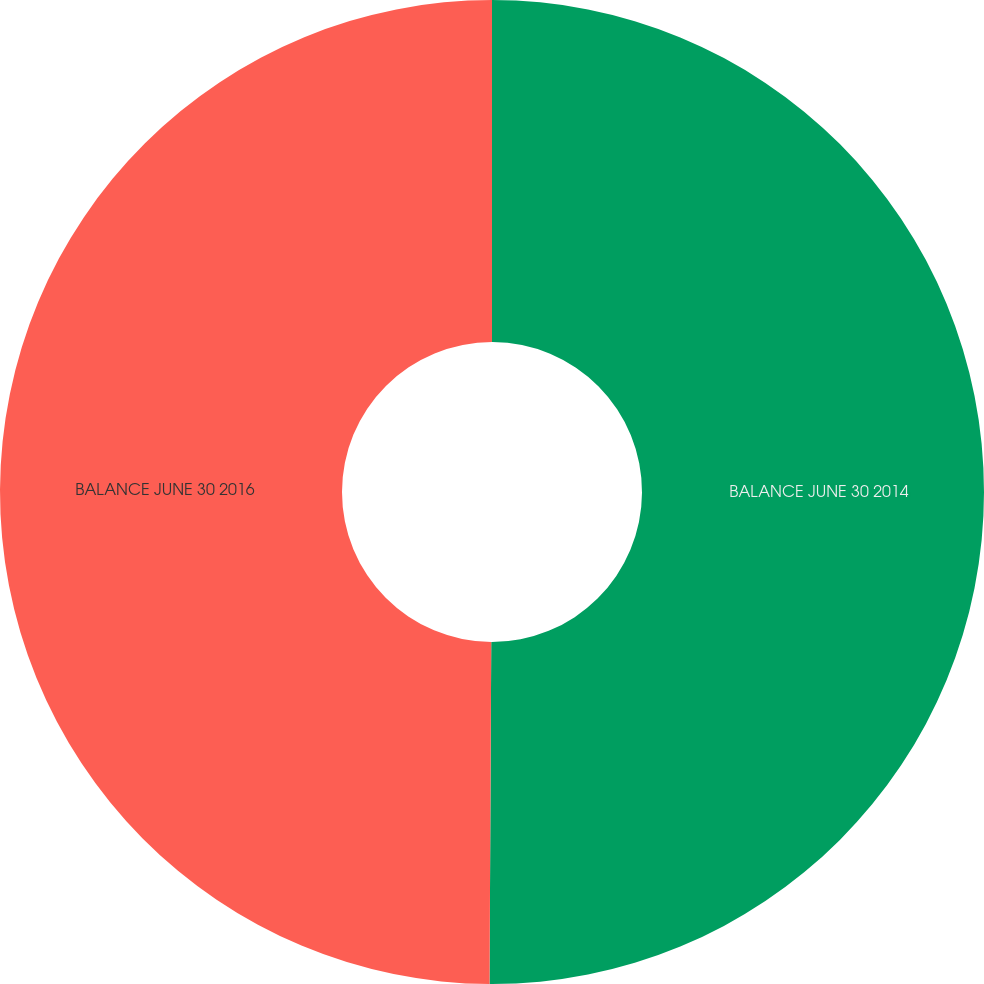Convert chart. <chart><loc_0><loc_0><loc_500><loc_500><pie_chart><fcel>BALANCE JUNE 30 2014<fcel>BALANCE JUNE 30 2016<nl><fcel>50.08%<fcel>49.92%<nl></chart> 